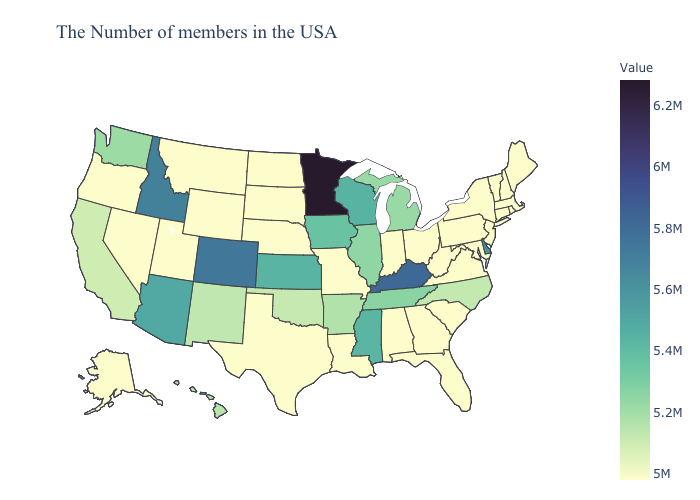Does the map have missing data?
Keep it brief. No. Does the map have missing data?
Write a very short answer. No. Which states have the lowest value in the USA?
Write a very short answer. Maine, Massachusetts, Rhode Island, New Hampshire, Vermont, Connecticut, New York, New Jersey, Maryland, Pennsylvania, Virginia, South Carolina, West Virginia, Ohio, Florida, Georgia, Indiana, Alabama, Louisiana, Missouri, Nebraska, Texas, South Dakota, North Dakota, Wyoming, Utah, Montana, Nevada, Oregon, Alaska. Does the map have missing data?
Be succinct. No. Does Minnesota have the highest value in the USA?
Quick response, please. Yes. Which states hav the highest value in the Northeast?
Short answer required. Maine, Massachusetts, Rhode Island, New Hampshire, Vermont, Connecticut, New York, New Jersey, Pennsylvania. Which states hav the highest value in the MidWest?
Be succinct. Minnesota. 